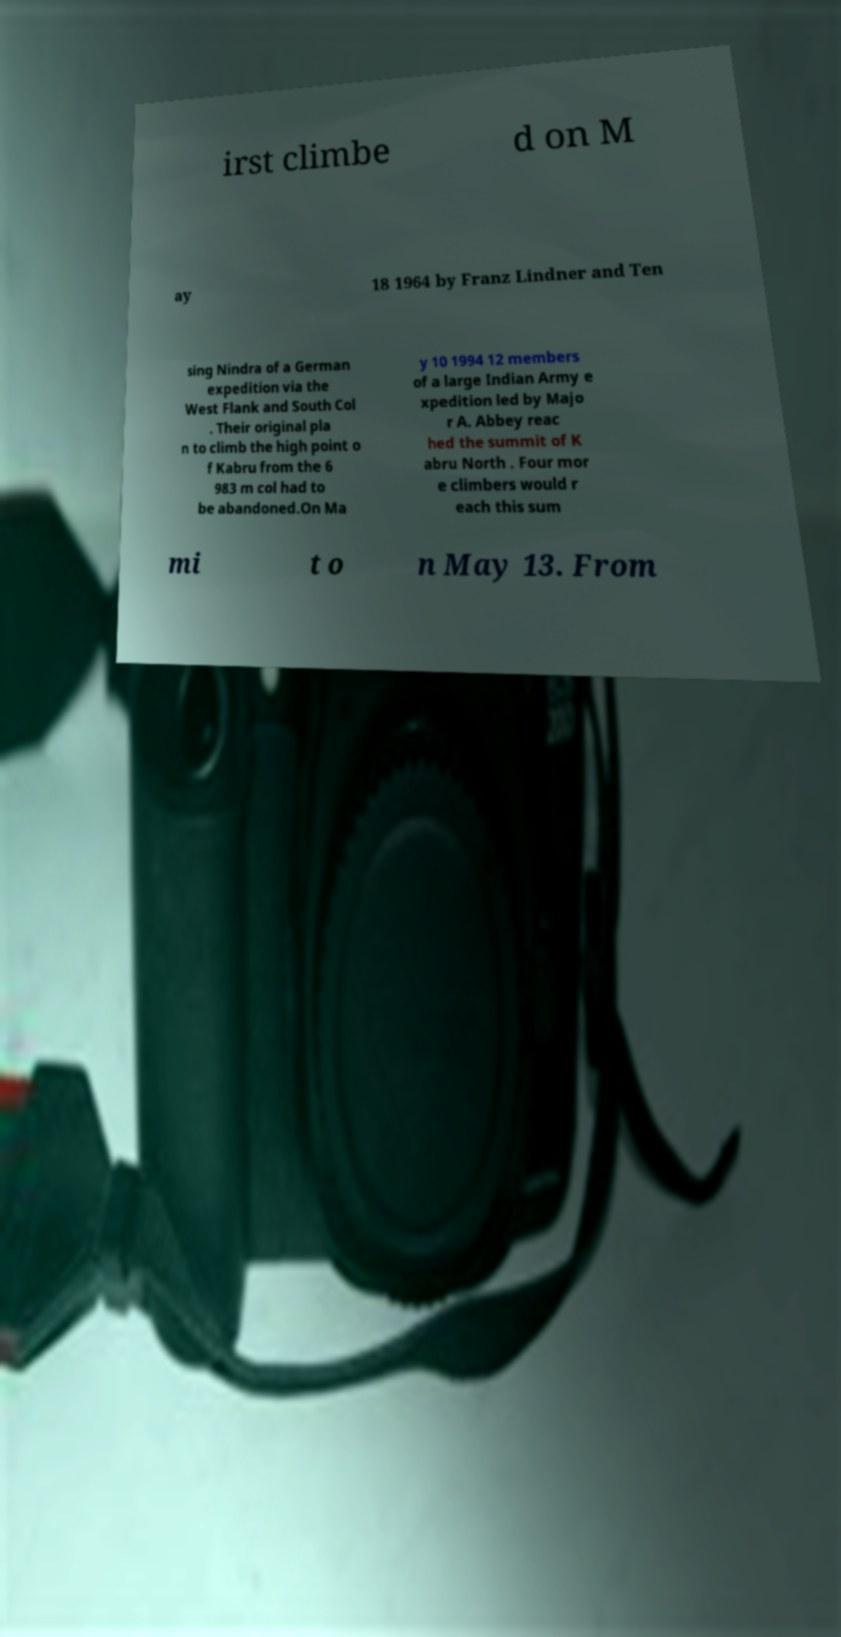What messages or text are displayed in this image? I need them in a readable, typed format. irst climbe d on M ay 18 1964 by Franz Lindner and Ten sing Nindra of a German expedition via the West Flank and South Col . Their original pla n to climb the high point o f Kabru from the 6 983 m col had to be abandoned.On Ma y 10 1994 12 members of a large Indian Army e xpedition led by Majo r A. Abbey reac hed the summit of K abru North . Four mor e climbers would r each this sum mi t o n May 13. From 